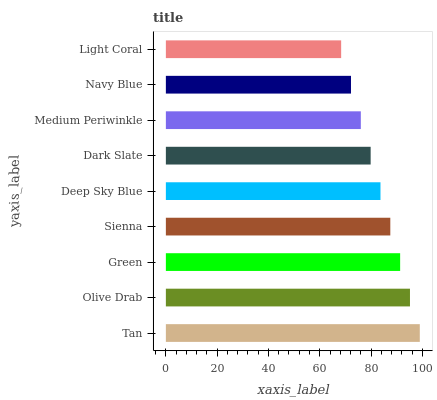Is Light Coral the minimum?
Answer yes or no. Yes. Is Tan the maximum?
Answer yes or no. Yes. Is Olive Drab the minimum?
Answer yes or no. No. Is Olive Drab the maximum?
Answer yes or no. No. Is Tan greater than Olive Drab?
Answer yes or no. Yes. Is Olive Drab less than Tan?
Answer yes or no. Yes. Is Olive Drab greater than Tan?
Answer yes or no. No. Is Tan less than Olive Drab?
Answer yes or no. No. Is Deep Sky Blue the high median?
Answer yes or no. Yes. Is Deep Sky Blue the low median?
Answer yes or no. Yes. Is Tan the high median?
Answer yes or no. No. Is Navy Blue the low median?
Answer yes or no. No. 